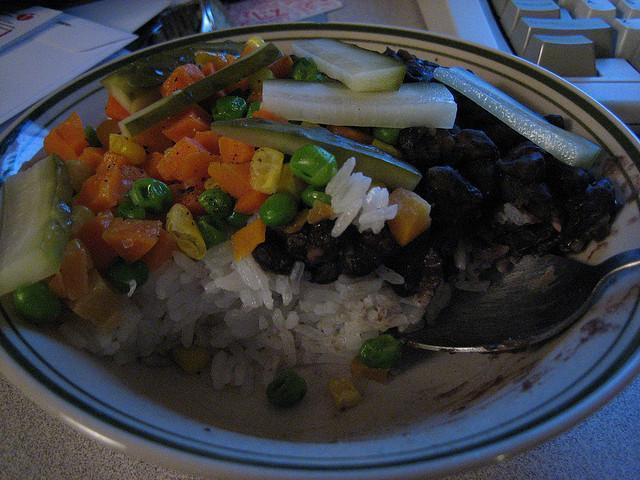What is available on this meal among the following ingredients options?
Indicate the correct choice and explain in the format: 'Answer: answer
Rationale: rationale.'
Options: Rice, beans, broccoli, kale. Answer: rice.
Rationale: A plate has food on it that is arranged on top of rice. 